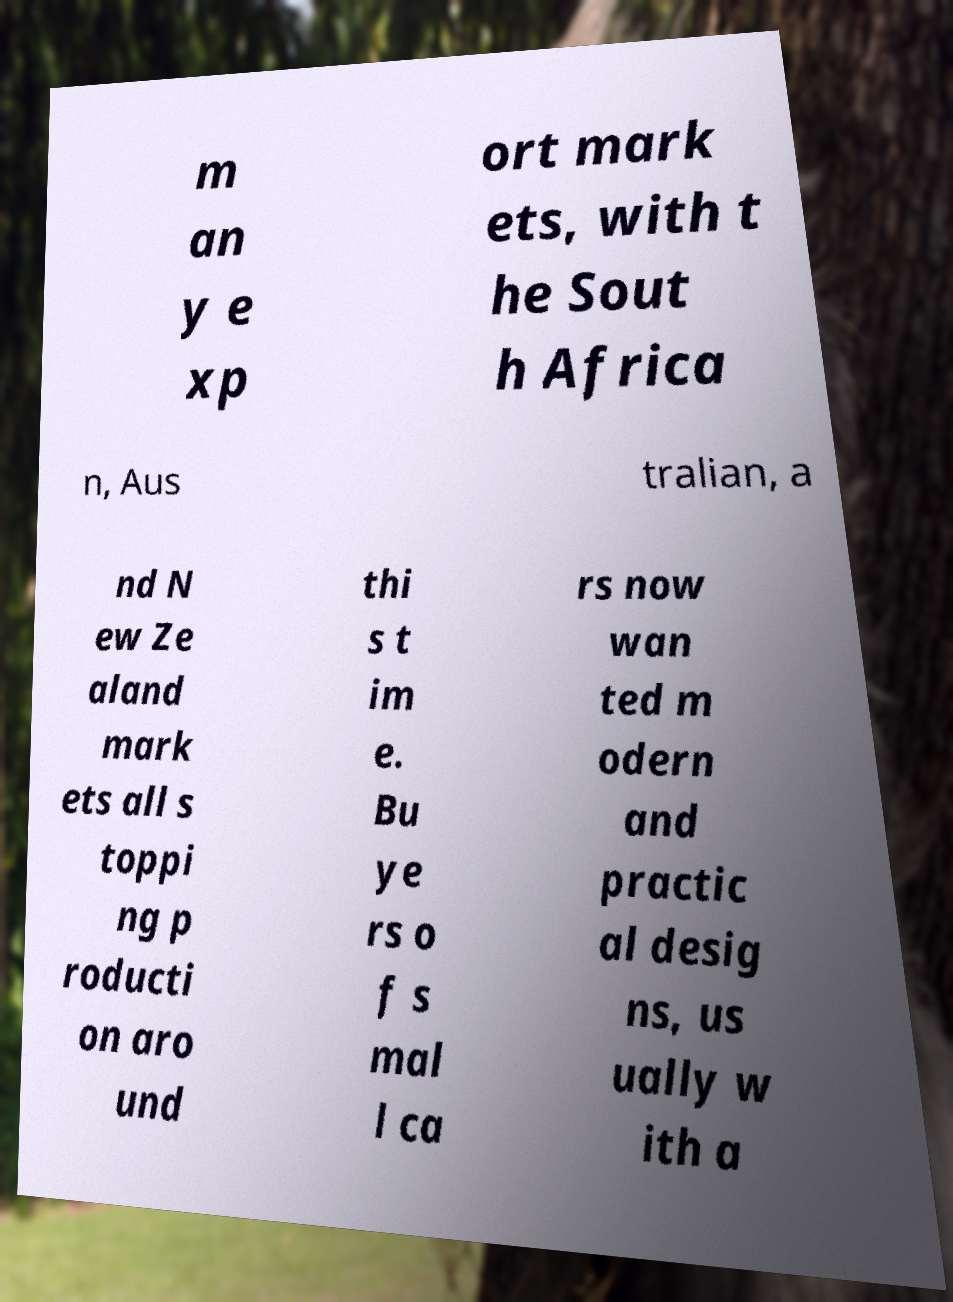For documentation purposes, I need the text within this image transcribed. Could you provide that? m an y e xp ort mark ets, with t he Sout h Africa n, Aus tralian, a nd N ew Ze aland mark ets all s toppi ng p roducti on aro und thi s t im e. Bu ye rs o f s mal l ca rs now wan ted m odern and practic al desig ns, us ually w ith a 